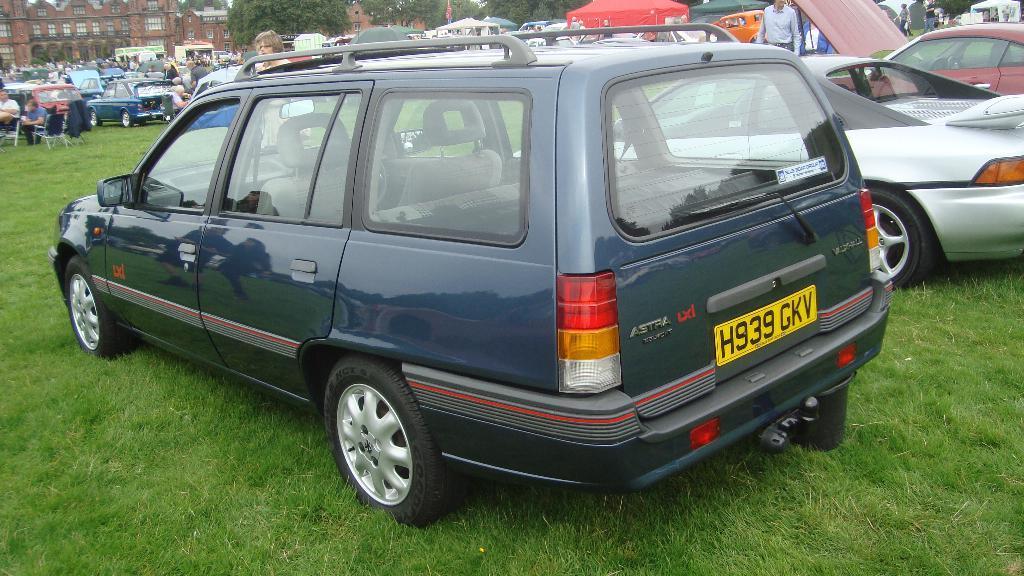Describe this image in one or two sentences. In this image I can see some grass on the ground and few vehicles on the ground. In the background I can see few persons, few trees which are green in color, few tents and few buildings which are brown in color. 